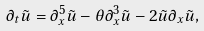<formula> <loc_0><loc_0><loc_500><loc_500>\partial _ { t } \tilde { u } = \partial _ { x } ^ { 5 } \tilde { u } - \theta \partial _ { x } ^ { 3 } \tilde { u } - 2 \tilde { u } \partial _ { x } \tilde { u } ,</formula> 